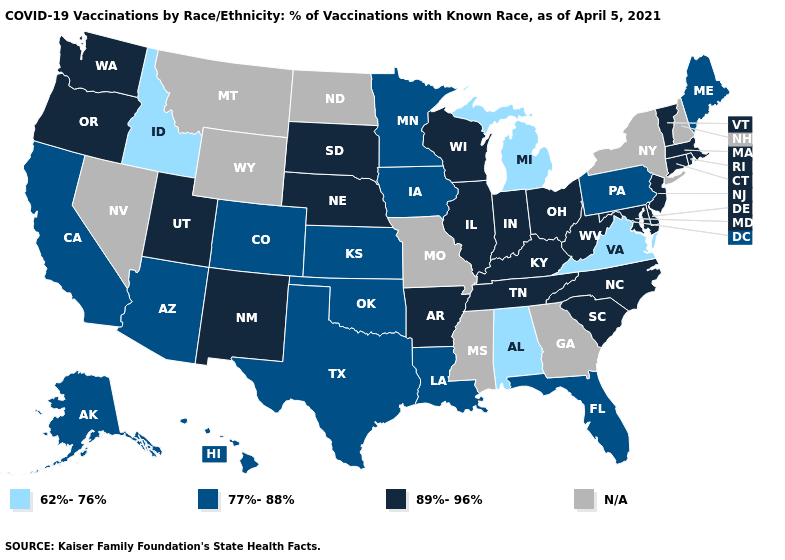Name the states that have a value in the range 77%-88%?
Be succinct. Alaska, Arizona, California, Colorado, Florida, Hawaii, Iowa, Kansas, Louisiana, Maine, Minnesota, Oklahoma, Pennsylvania, Texas. Name the states that have a value in the range 62%-76%?
Keep it brief. Alabama, Idaho, Michigan, Virginia. Among the states that border Nevada , does Idaho have the highest value?
Give a very brief answer. No. Name the states that have a value in the range N/A?
Short answer required. Georgia, Mississippi, Missouri, Montana, Nevada, New Hampshire, New York, North Dakota, Wyoming. What is the highest value in states that border North Carolina?
Quick response, please. 89%-96%. Does Pennsylvania have the lowest value in the Northeast?
Quick response, please. Yes. What is the value of Connecticut?
Answer briefly. 89%-96%. Name the states that have a value in the range 77%-88%?
Give a very brief answer. Alaska, Arizona, California, Colorado, Florida, Hawaii, Iowa, Kansas, Louisiana, Maine, Minnesota, Oklahoma, Pennsylvania, Texas. Does Louisiana have the highest value in the South?
Give a very brief answer. No. What is the highest value in the USA?
Be succinct. 89%-96%. What is the value of Colorado?
Answer briefly. 77%-88%. What is the value of Delaware?
Concise answer only. 89%-96%. 